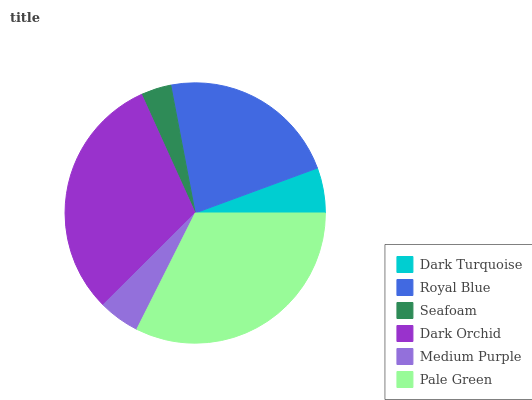Is Seafoam the minimum?
Answer yes or no. Yes. Is Pale Green the maximum?
Answer yes or no. Yes. Is Royal Blue the minimum?
Answer yes or no. No. Is Royal Blue the maximum?
Answer yes or no. No. Is Royal Blue greater than Dark Turquoise?
Answer yes or no. Yes. Is Dark Turquoise less than Royal Blue?
Answer yes or no. Yes. Is Dark Turquoise greater than Royal Blue?
Answer yes or no. No. Is Royal Blue less than Dark Turquoise?
Answer yes or no. No. Is Royal Blue the high median?
Answer yes or no. Yes. Is Dark Turquoise the low median?
Answer yes or no. Yes. Is Seafoam the high median?
Answer yes or no. No. Is Royal Blue the low median?
Answer yes or no. No. 